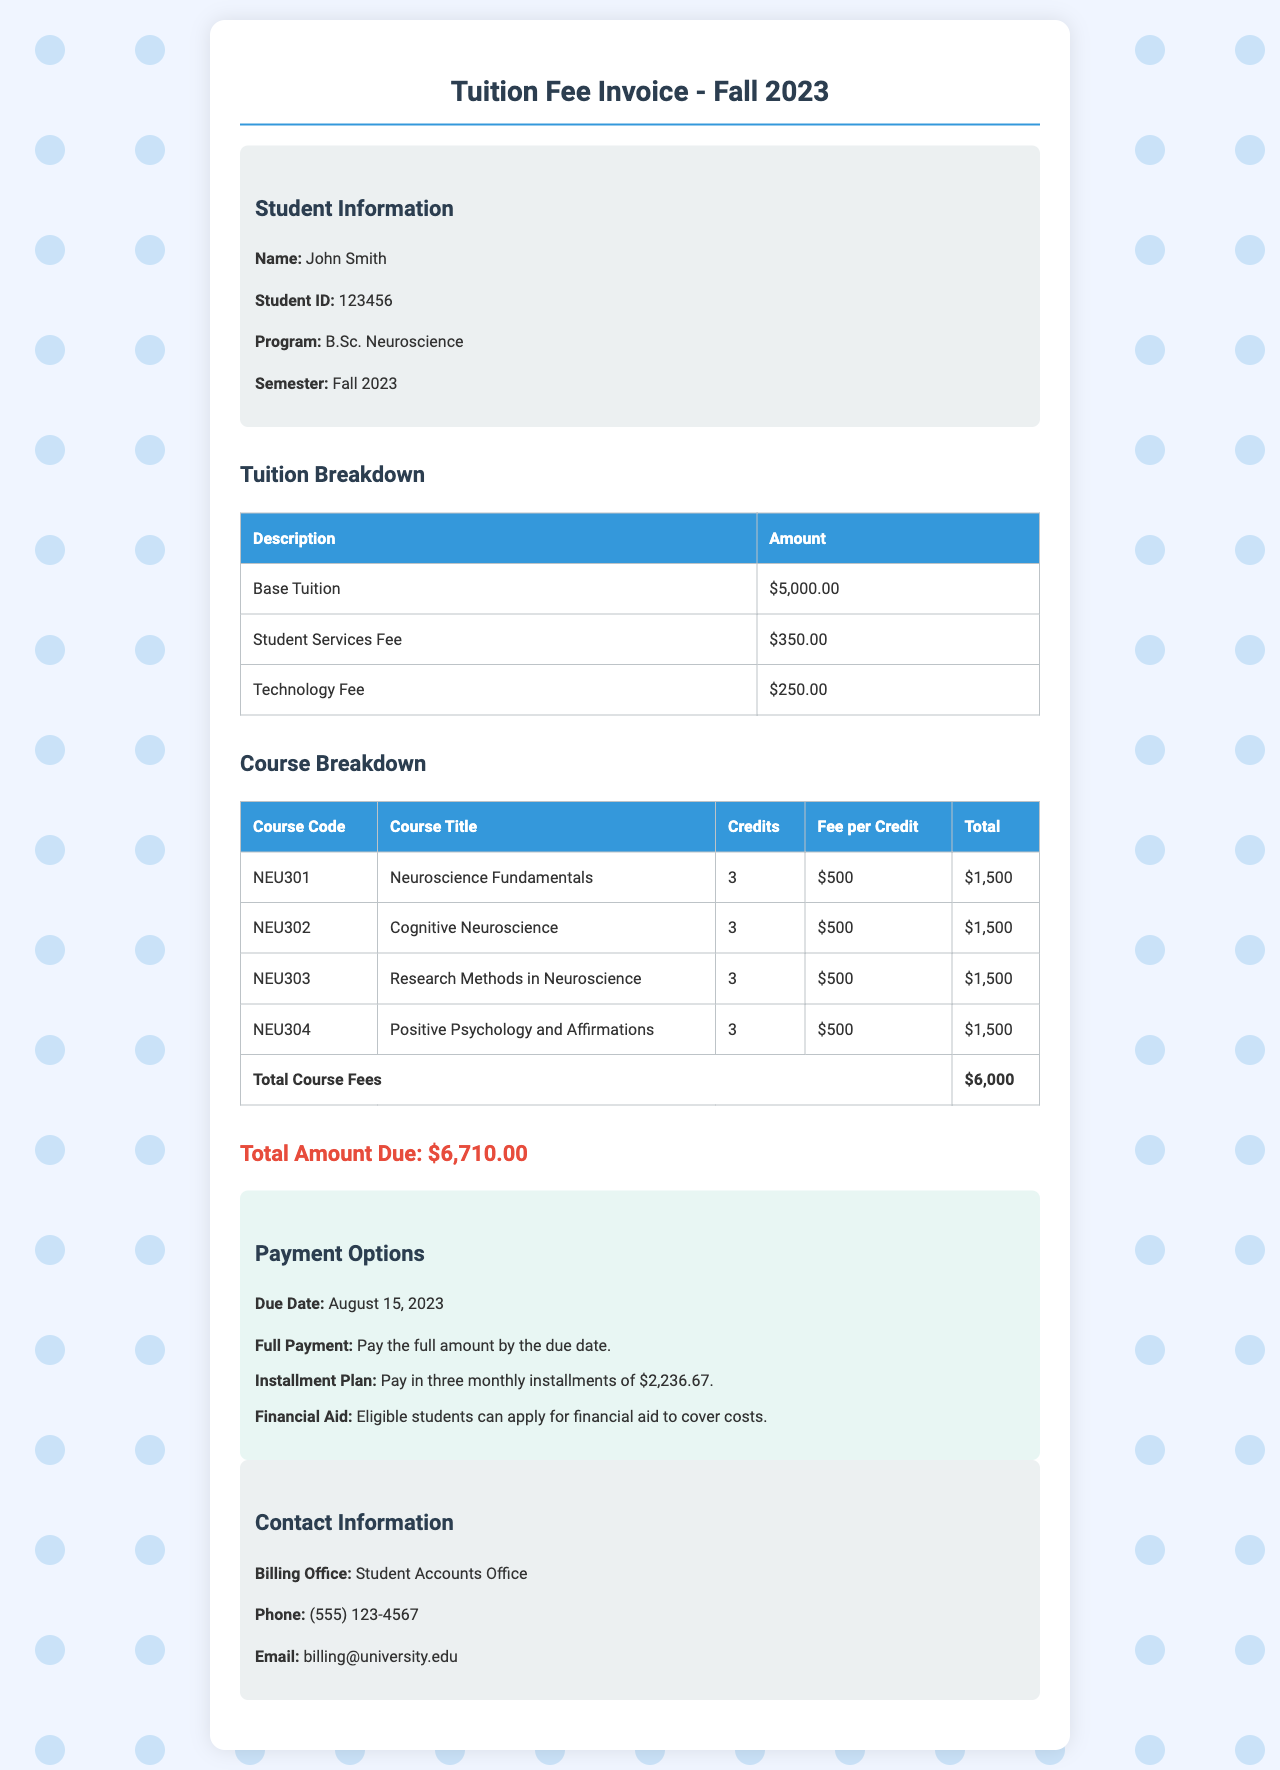What is the due date for the tuition payment? The due date for the tuition payment is explicitly mentioned in the payment options section of the document.
Answer: August 15, 2023 How much is the total amount due? The total amount due is clearly stated in the document in the total section.
Answer: $6,710.00 What course covers Positive Psychology and Affirmations? The document lists the courses along with their titles, including the one on Positive Psychology and Affirmations.
Answer: Positive Psychology and Affirmations What is the base tuition fee? The base tuition fee is specified in the tuition breakdown section of the document.
Answer: $5,000.00 How many courses are listed in the course breakdown? By counting the courses listed in the course breakdown table, we can determine the total number.
Answer: 4 How much is the technology fee? The technology fee is mentioned in the tuition breakdown section.
Answer: $250.00 What is the total course fees amount? The document provides a specific total for the course fees in the course breakdown section.
Answer: $6,000 What are the installment amounts for the payment plan? The payment options section describes the installment plan, including the amount of each installment.
Answer: $2,236.67 Who can apply for financial aid? The document indicates eligibility for financial aid in the payment options section without specifying who is eligible, inferring it relates to students.
Answer: Eligible students 